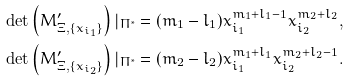<formula> <loc_0><loc_0><loc_500><loc_500>\det \left ( M ^ { \prime } _ { \Xi , \{ x _ { i _ { 1 } } \} } \right ) | _ { \Pi ^ { * } } & = ( m _ { 1 } - l _ { 1 } ) x _ { i _ { 1 } } ^ { m _ { 1 } + l _ { 1 } - 1 } x _ { i _ { 2 } } ^ { m _ { 2 } + l _ { 2 } } , \\ \det \left ( M ^ { \prime } _ { \Xi , \{ x _ { i _ { 2 } } \} } \right ) | _ { \Pi ^ { * } } & = ( m _ { 2 } - l _ { 2 } ) x _ { i _ { 1 } } ^ { m _ { 1 } + l _ { 1 } } x _ { i _ { 2 } } ^ { m _ { 2 } + l _ { 2 } - 1 } .</formula> 